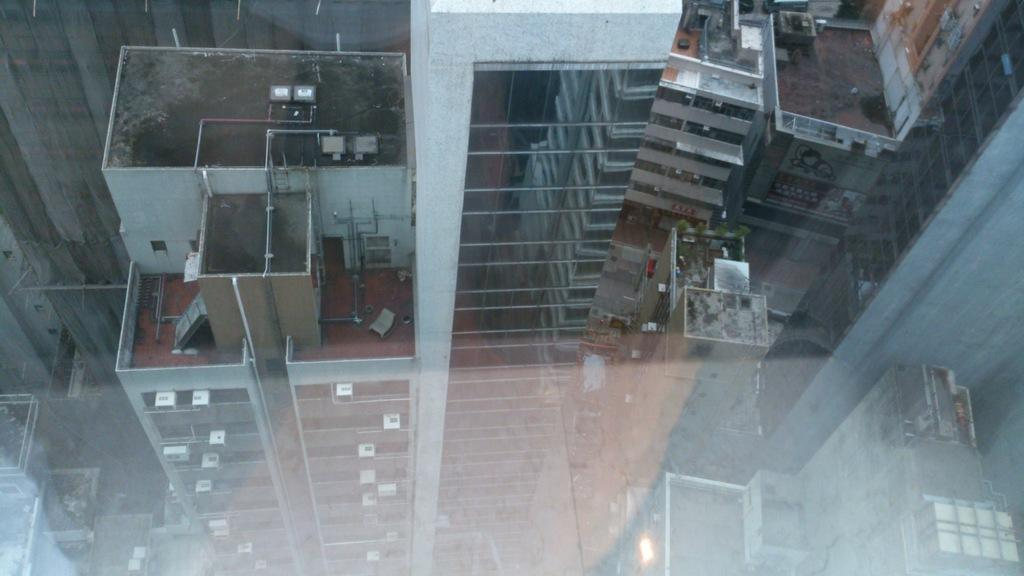What type of structures are visible in the image? There are buildings in the image. What feature can be seen on the buildings? There are windows in the image. How many accounts are mentioned in the image? There are no accounts mentioned in the image, as it only features buildings and windows. 